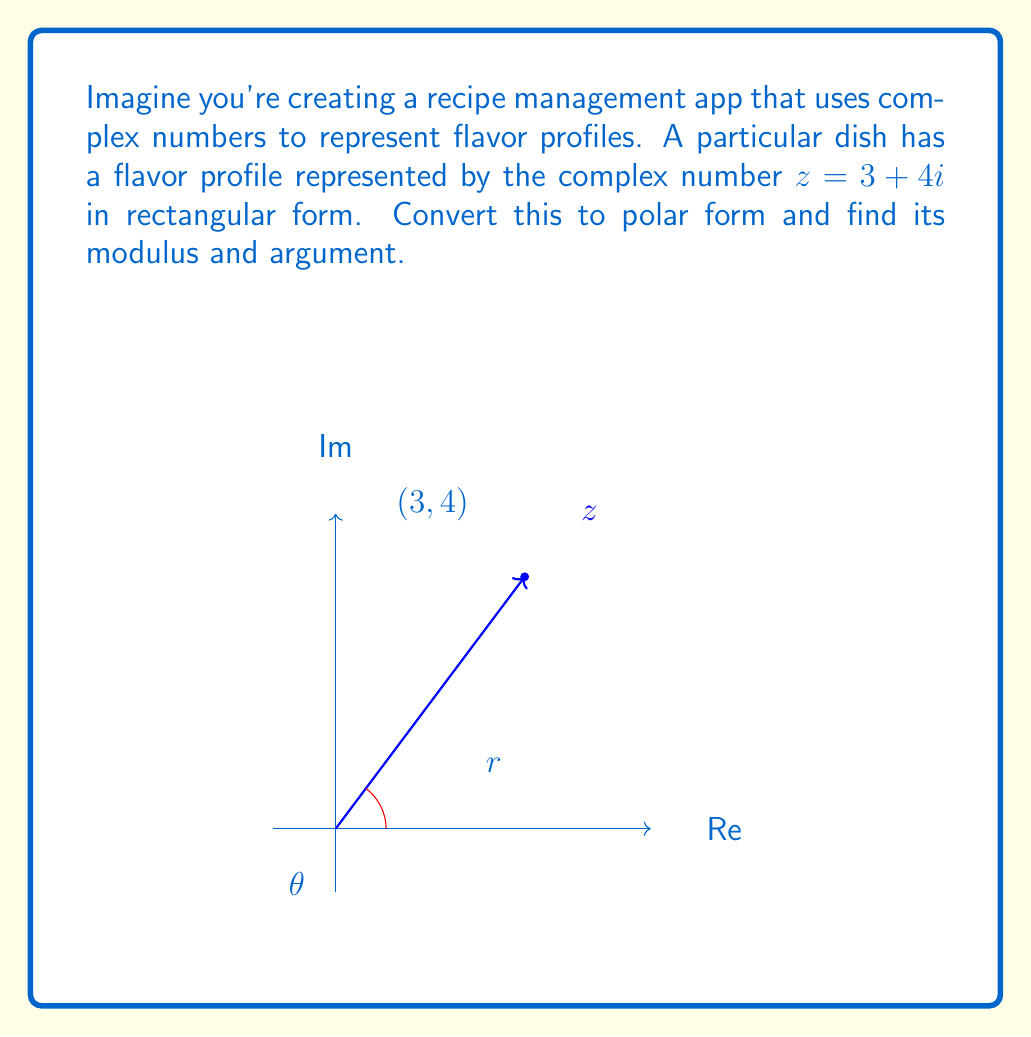Help me with this question. Let's approach this step-by-step:

1) The polar form of a complex number is given by $r(\cos\theta + i\sin\theta)$ or $re^{i\theta}$, where $r$ is the modulus and $\theta$ is the argument.

2) To find the modulus $r$:
   $$r = \sqrt{a^2 + b^2}$$
   where $a$ is the real part and $b$ is the imaginary part.
   
   $$r = \sqrt{3^2 + 4^2} = \sqrt{9 + 16} = \sqrt{25} = 5$$

3) To find the argument $\theta$:
   $$\theta = \tan^{-1}\left(\frac{b}{a}\right)$$
   
   $$\theta = \tan^{-1}\left(\frac{4}{3}\right) \approx 0.9273 \text{ radians}$$

4) Converting to degrees:
   $$0.9273 \text{ radians} \times \frac{180°}{\pi} \approx 53.13°$$

5) Therefore, in polar form:
   $$z = 5(\cos 53.13° + i\sin 53.13°) = 5e^{i53.13°}$$

The modulus is 5, and the argument is approximately 53.13° or 0.9273 radians.
Answer: Modulus: 5, Argument: 53.13° or 0.9273 radians 